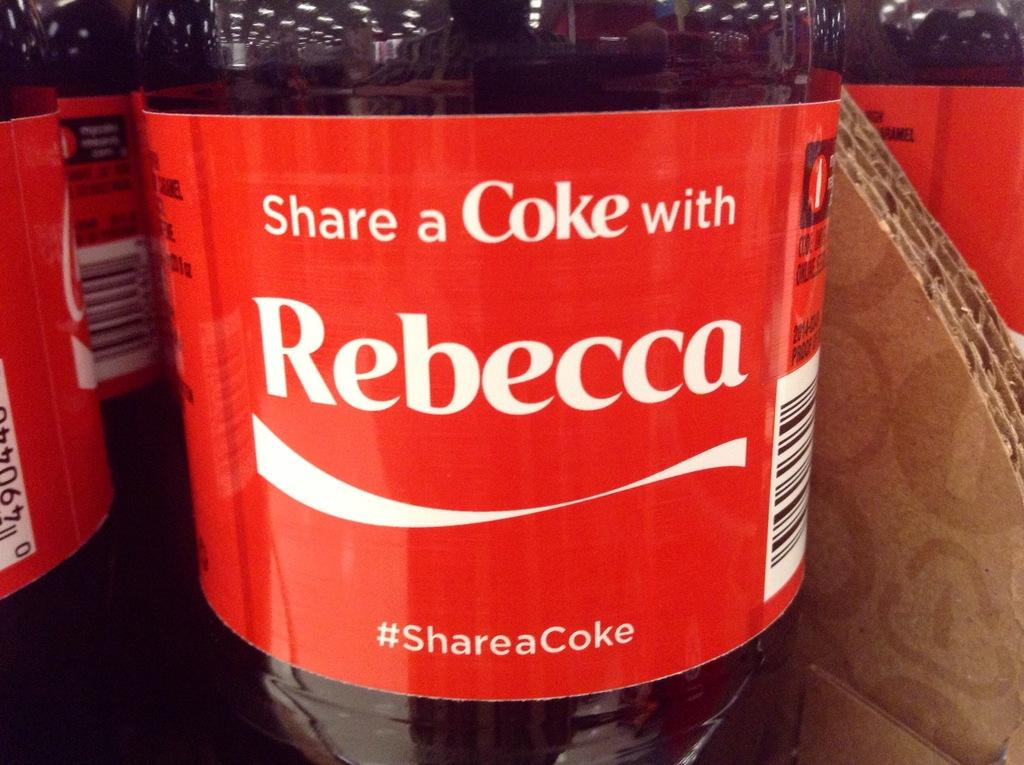<image>
Present a compact description of the photo's key features. A red Coke bottle has the name Rebecca on the front. 